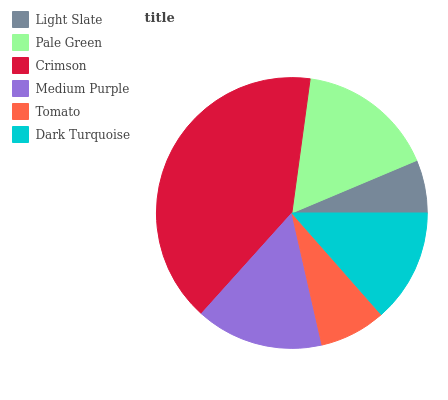Is Light Slate the minimum?
Answer yes or no. Yes. Is Crimson the maximum?
Answer yes or no. Yes. Is Pale Green the minimum?
Answer yes or no. No. Is Pale Green the maximum?
Answer yes or no. No. Is Pale Green greater than Light Slate?
Answer yes or no. Yes. Is Light Slate less than Pale Green?
Answer yes or no. Yes. Is Light Slate greater than Pale Green?
Answer yes or no. No. Is Pale Green less than Light Slate?
Answer yes or no. No. Is Medium Purple the high median?
Answer yes or no. Yes. Is Dark Turquoise the low median?
Answer yes or no. Yes. Is Pale Green the high median?
Answer yes or no. No. Is Medium Purple the low median?
Answer yes or no. No. 